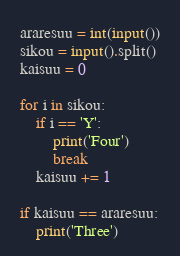Convert code to text. <code><loc_0><loc_0><loc_500><loc_500><_Python_>araresuu = int(input())
sikou = input().split()
kaisuu = 0

for i in sikou:
    if i == 'Y':
        print('Four')
        break
    kaisuu += 1

if kaisuu == araresuu:
    print('Three')
</code> 